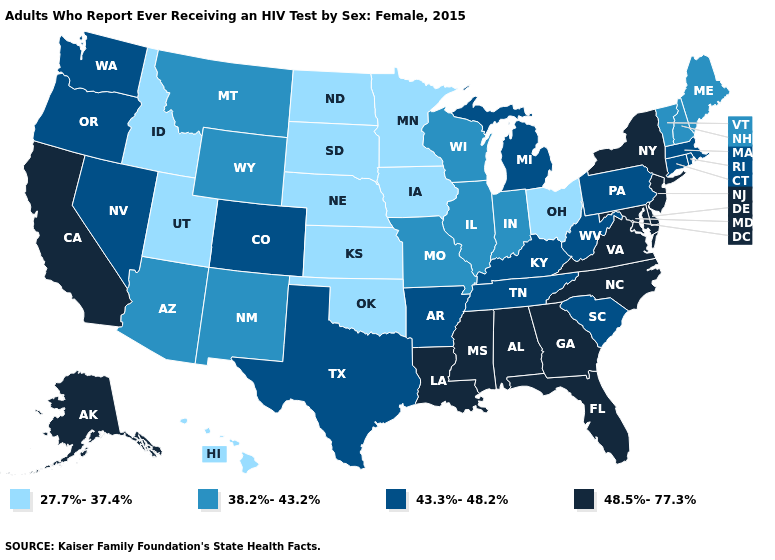What is the value of Minnesota?
Write a very short answer. 27.7%-37.4%. What is the value of North Dakota?
Short answer required. 27.7%-37.4%. Name the states that have a value in the range 38.2%-43.2%?
Write a very short answer. Arizona, Illinois, Indiana, Maine, Missouri, Montana, New Hampshire, New Mexico, Vermont, Wisconsin, Wyoming. Does Alaska have the highest value in the West?
Quick response, please. Yes. Does the first symbol in the legend represent the smallest category?
Answer briefly. Yes. Does the map have missing data?
Write a very short answer. No. Name the states that have a value in the range 48.5%-77.3%?
Answer briefly. Alabama, Alaska, California, Delaware, Florida, Georgia, Louisiana, Maryland, Mississippi, New Jersey, New York, North Carolina, Virginia. Which states have the lowest value in the Northeast?
Quick response, please. Maine, New Hampshire, Vermont. Which states have the lowest value in the South?
Keep it brief. Oklahoma. What is the highest value in the USA?
Be succinct. 48.5%-77.3%. What is the value of Oklahoma?
Give a very brief answer. 27.7%-37.4%. Among the states that border South Carolina , which have the lowest value?
Keep it brief. Georgia, North Carolina. Among the states that border Illinois , does Kentucky have the lowest value?
Short answer required. No. Does Connecticut have the highest value in the USA?
Keep it brief. No. What is the value of Iowa?
Write a very short answer. 27.7%-37.4%. 